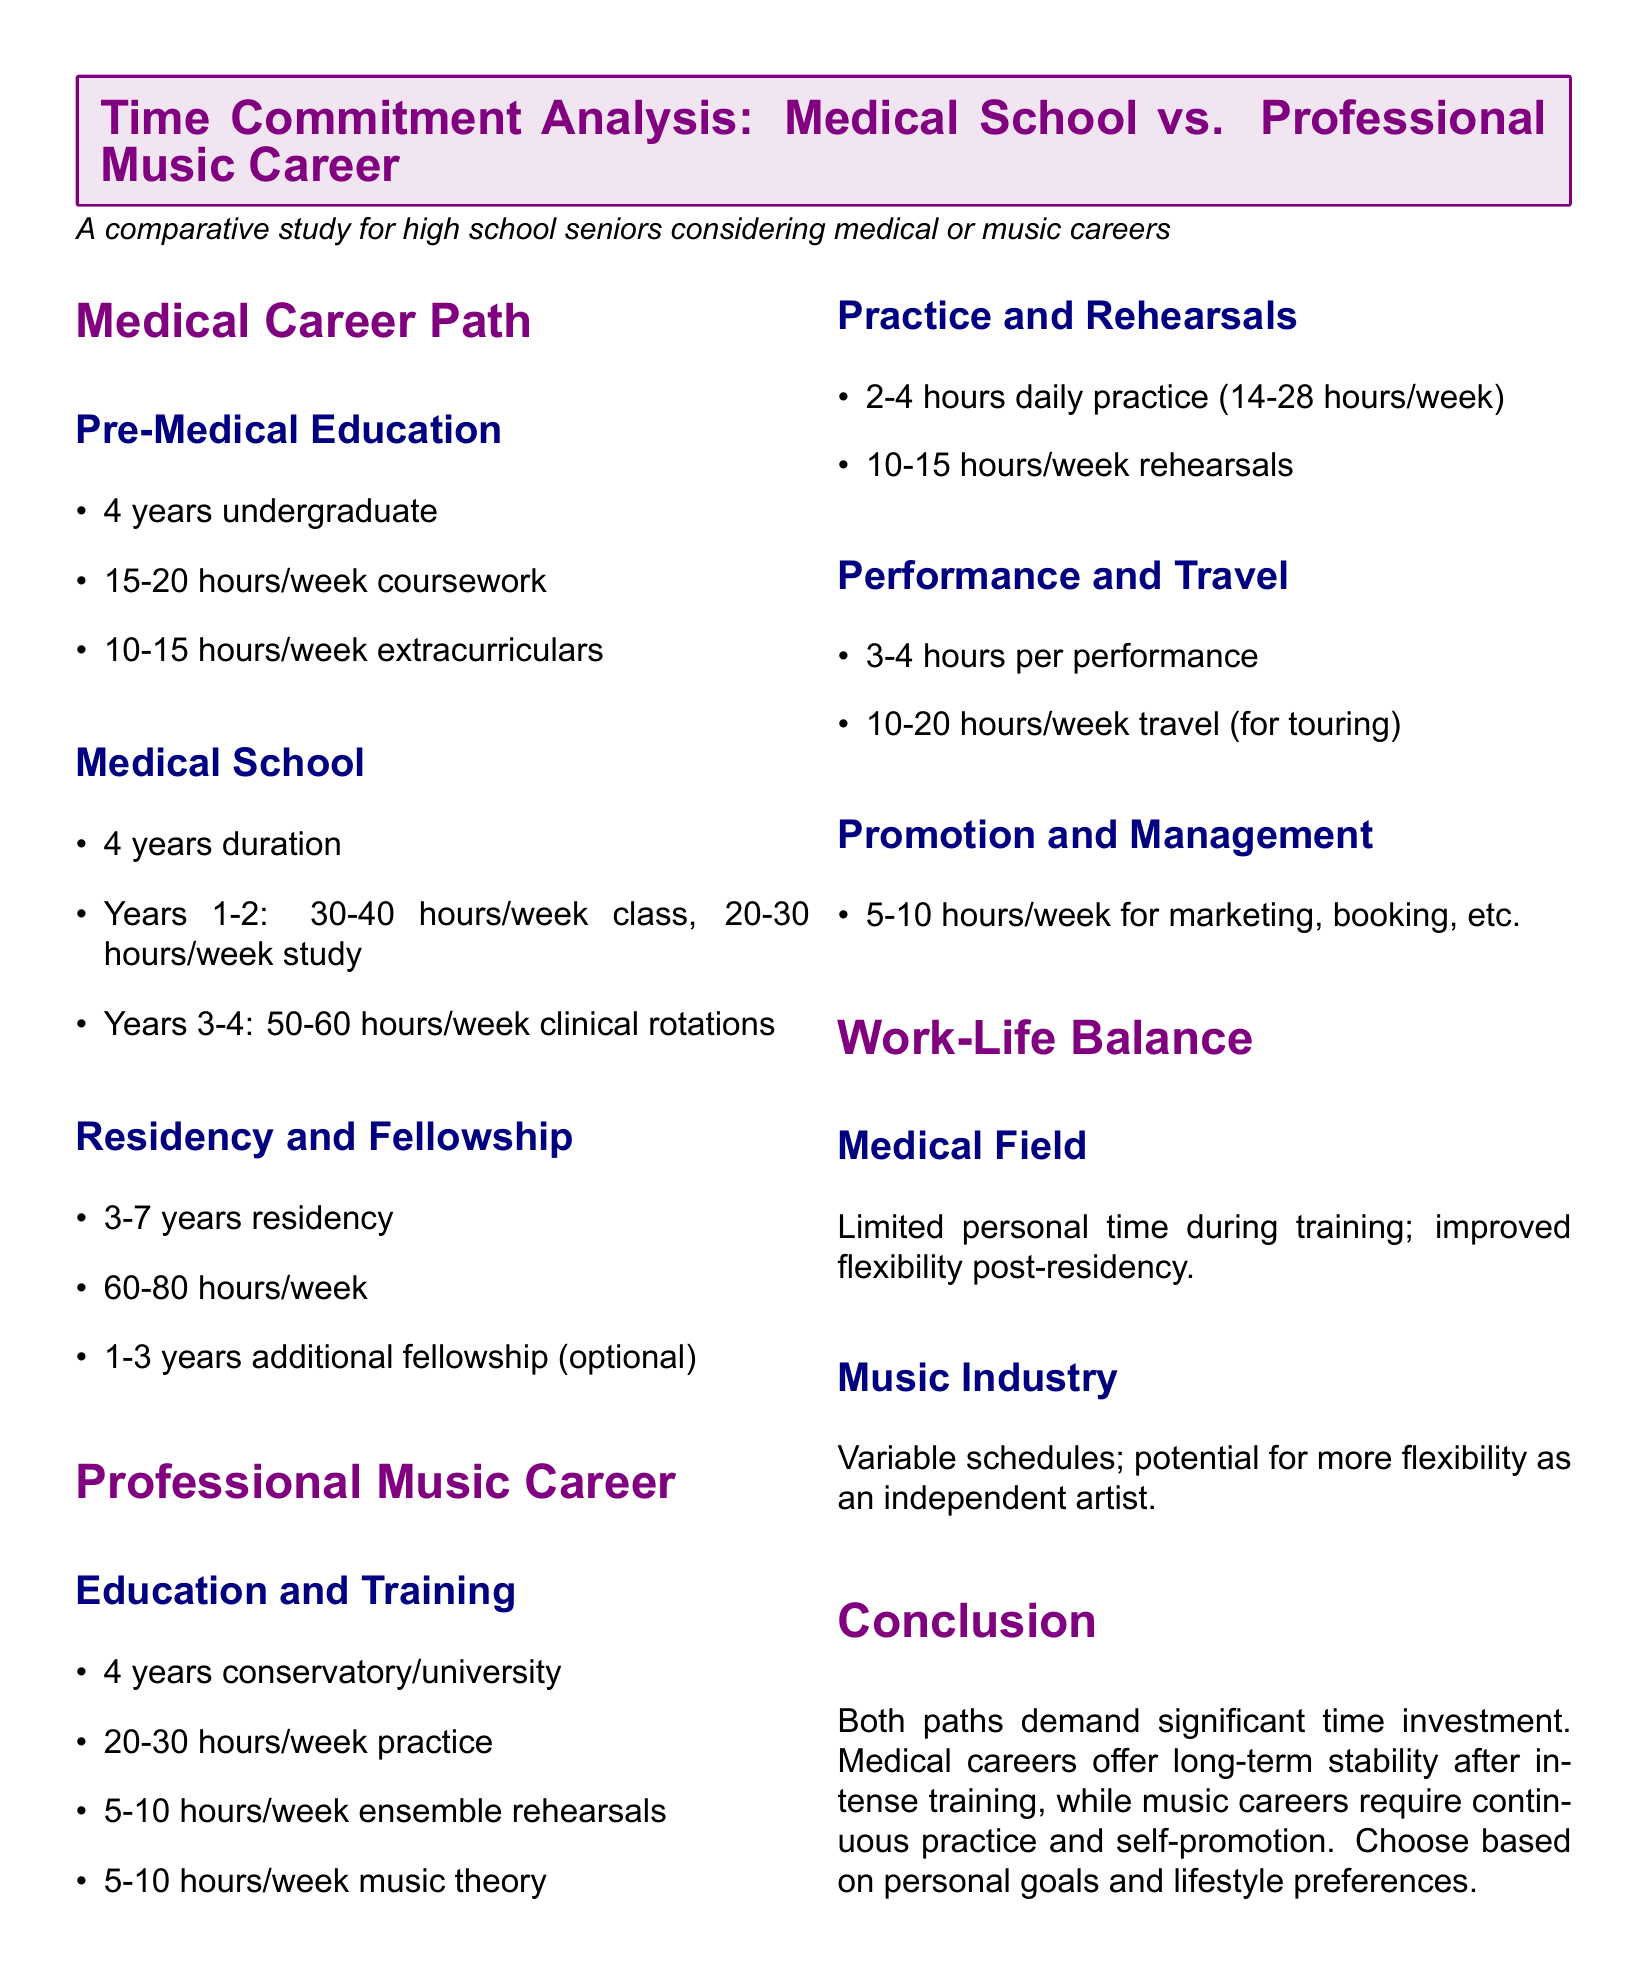What is the typical undergraduate duration before medical school? The document lists this duration as 4 years.
Answer: 4 years How many hours per week are spent on class during the first two years of medical school? The document states this is between 30-40 hours per week.
Answer: 30-40 hours/week What is the daily practice time suggested for a professional musician? The document mentions this as 2-4 hours daily.
Answer: 2-4 hours What is the maximum weekly commitment for medical residency? The document notes this commitment is between 60-80 hours/week.
Answer: 60-80 hours/week How many hours per week are recommended for music theory during education? The document specifies this as 5-10 hours/week.
Answer: 5-10 hours/week What aspect of work-life balance is highlighted for the medical field? The document states there is limited personal time during training.
Answer: Limited personal time What is the time commitment for promotion and management in a music career? The document indicates this is 5-10 hours/week.
Answer: 5-10 hours/week What is the primary factor influencing the choice between a medical and music career according to the conclusion? The document emphasizes personal goals and lifestyle preferences as the key factor.
Answer: Personal goals and lifestyle preferences 